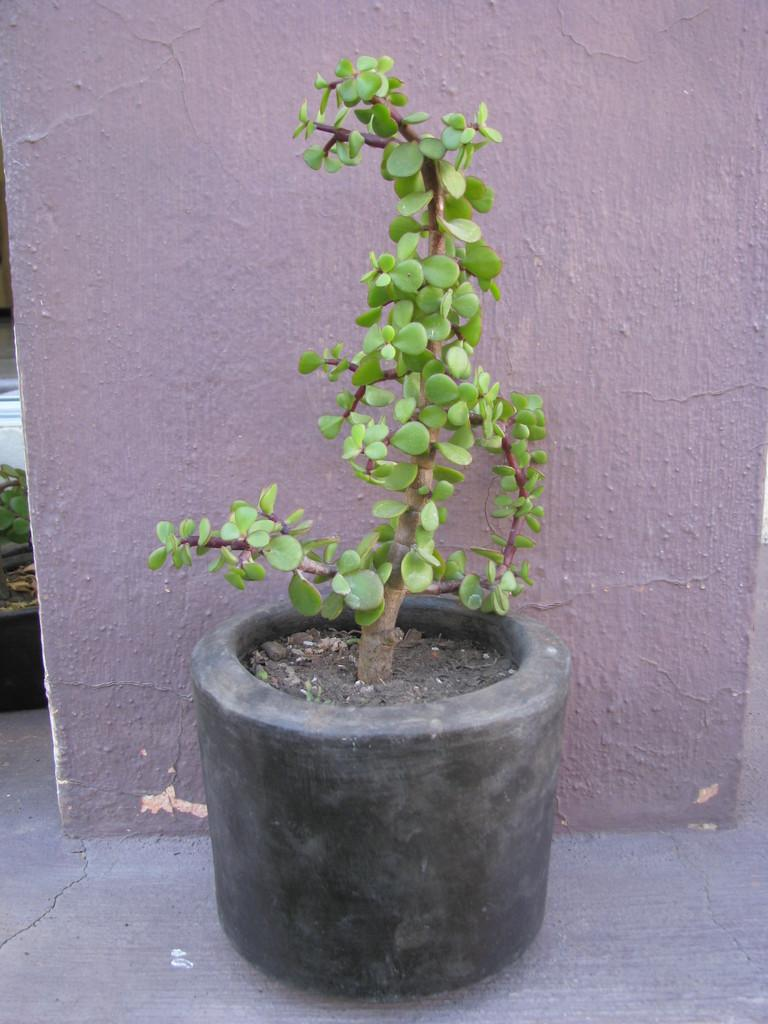What type of plant can be seen on the floor in the image? There is a houseplant on the floor in the image. What can be seen in the background of the image? There is a wall visible in the background of the image. When was the image taken? The image was taken during the day. Where was the image taken? The image was taken outside a house. How many flowers are on the ball in the image? There are no flowers or balls present in the image; it features a houseplant on the floor and a wall in the background. 